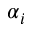Convert formula to latex. <formula><loc_0><loc_0><loc_500><loc_500>\alpha _ { i }</formula> 